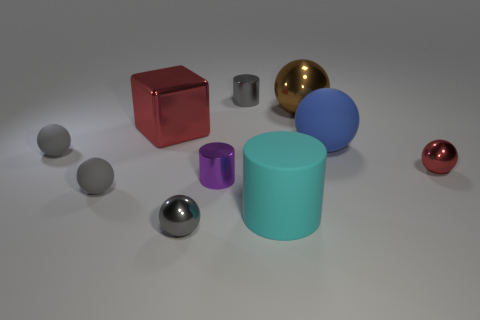Is the block the same color as the big rubber sphere?
Offer a very short reply. No. Are there more big blue spheres that are left of the red cube than gray things?
Your answer should be compact. No. What number of other things are the same material as the large red cube?
Your response must be concise. 5. What number of large things are blue metallic things or purple shiny things?
Ensure brevity in your answer.  0. Are the small purple object and the large brown ball made of the same material?
Give a very brief answer. Yes. What number of blue rubber balls are to the left of the small matte ball in front of the tiny purple cylinder?
Ensure brevity in your answer.  0. Is there a blue object that has the same shape as the large red thing?
Keep it short and to the point. No. Is the shape of the object in front of the big cylinder the same as the small gray matte thing that is in front of the tiny purple thing?
Provide a short and direct response. Yes. There is a big object that is behind the cyan rubber thing and left of the brown metallic ball; what is its shape?
Offer a terse response. Cube. Are there any red things that have the same size as the red cube?
Ensure brevity in your answer.  No. 